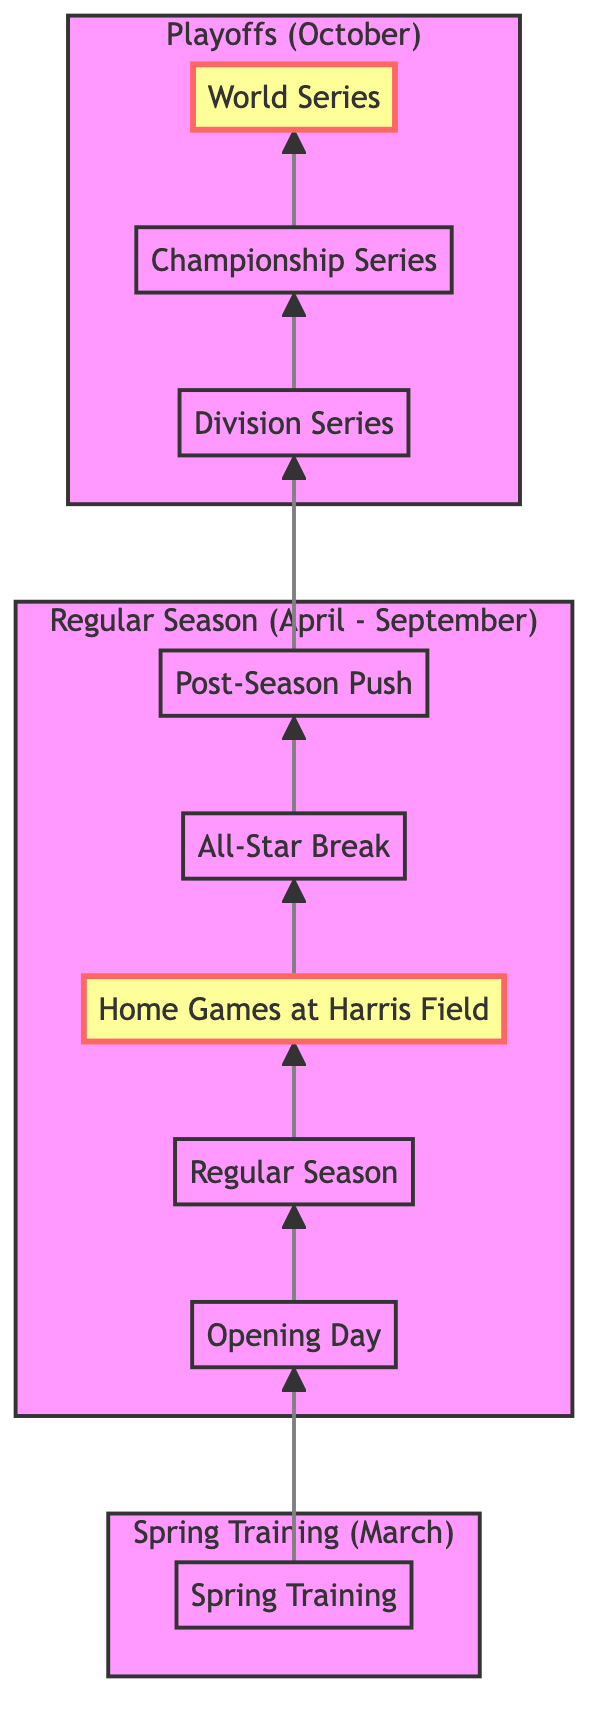What does the diagram start with? The bottom of the flow chart begins with "Spring Training," which is the initial phase depicted.
Answer: Spring Training What follows Opening Day in the diagram? Following the arrow from "Opening Day," the next node is "Regular Season."
Answer: Regular Season How many main sections are represented in the diagram? The diagram is divided into three main sections: Spring Training, Regular Season, and Playoffs, which can be counted as three distinct groups.
Answer: Three Which event is highlighted as a home game venue in the Regular Season? The diagram highlights "Home Games at Harris Field" within the Regular Season section in a distinct color.
Answer: Home Games at Harris Field What happens after the All-Star Break? The arrow indicates that the next step after the "All-Star Break" is "Post-Season Push."
Answer: Post-Season Push In what month does the Playoffs section begin? The Playoffs section starts in October, as indicated in the description of that segment.
Answer: October How many games are played in the Division Series? The Division Series involves "Best-of-Five Games" as stated in the associated events.
Answer: Best-of-Five Games Which two playoff stages lead to the final World Series? The two playoff stages leading to the World Series are "Championship Series" and then "World Series."
Answer: Championship Series and World Series What color represents the Playoffs section in the diagram? The Playoffs section is represented with a light red color as described in the styling of that section.
Answer: Light red 